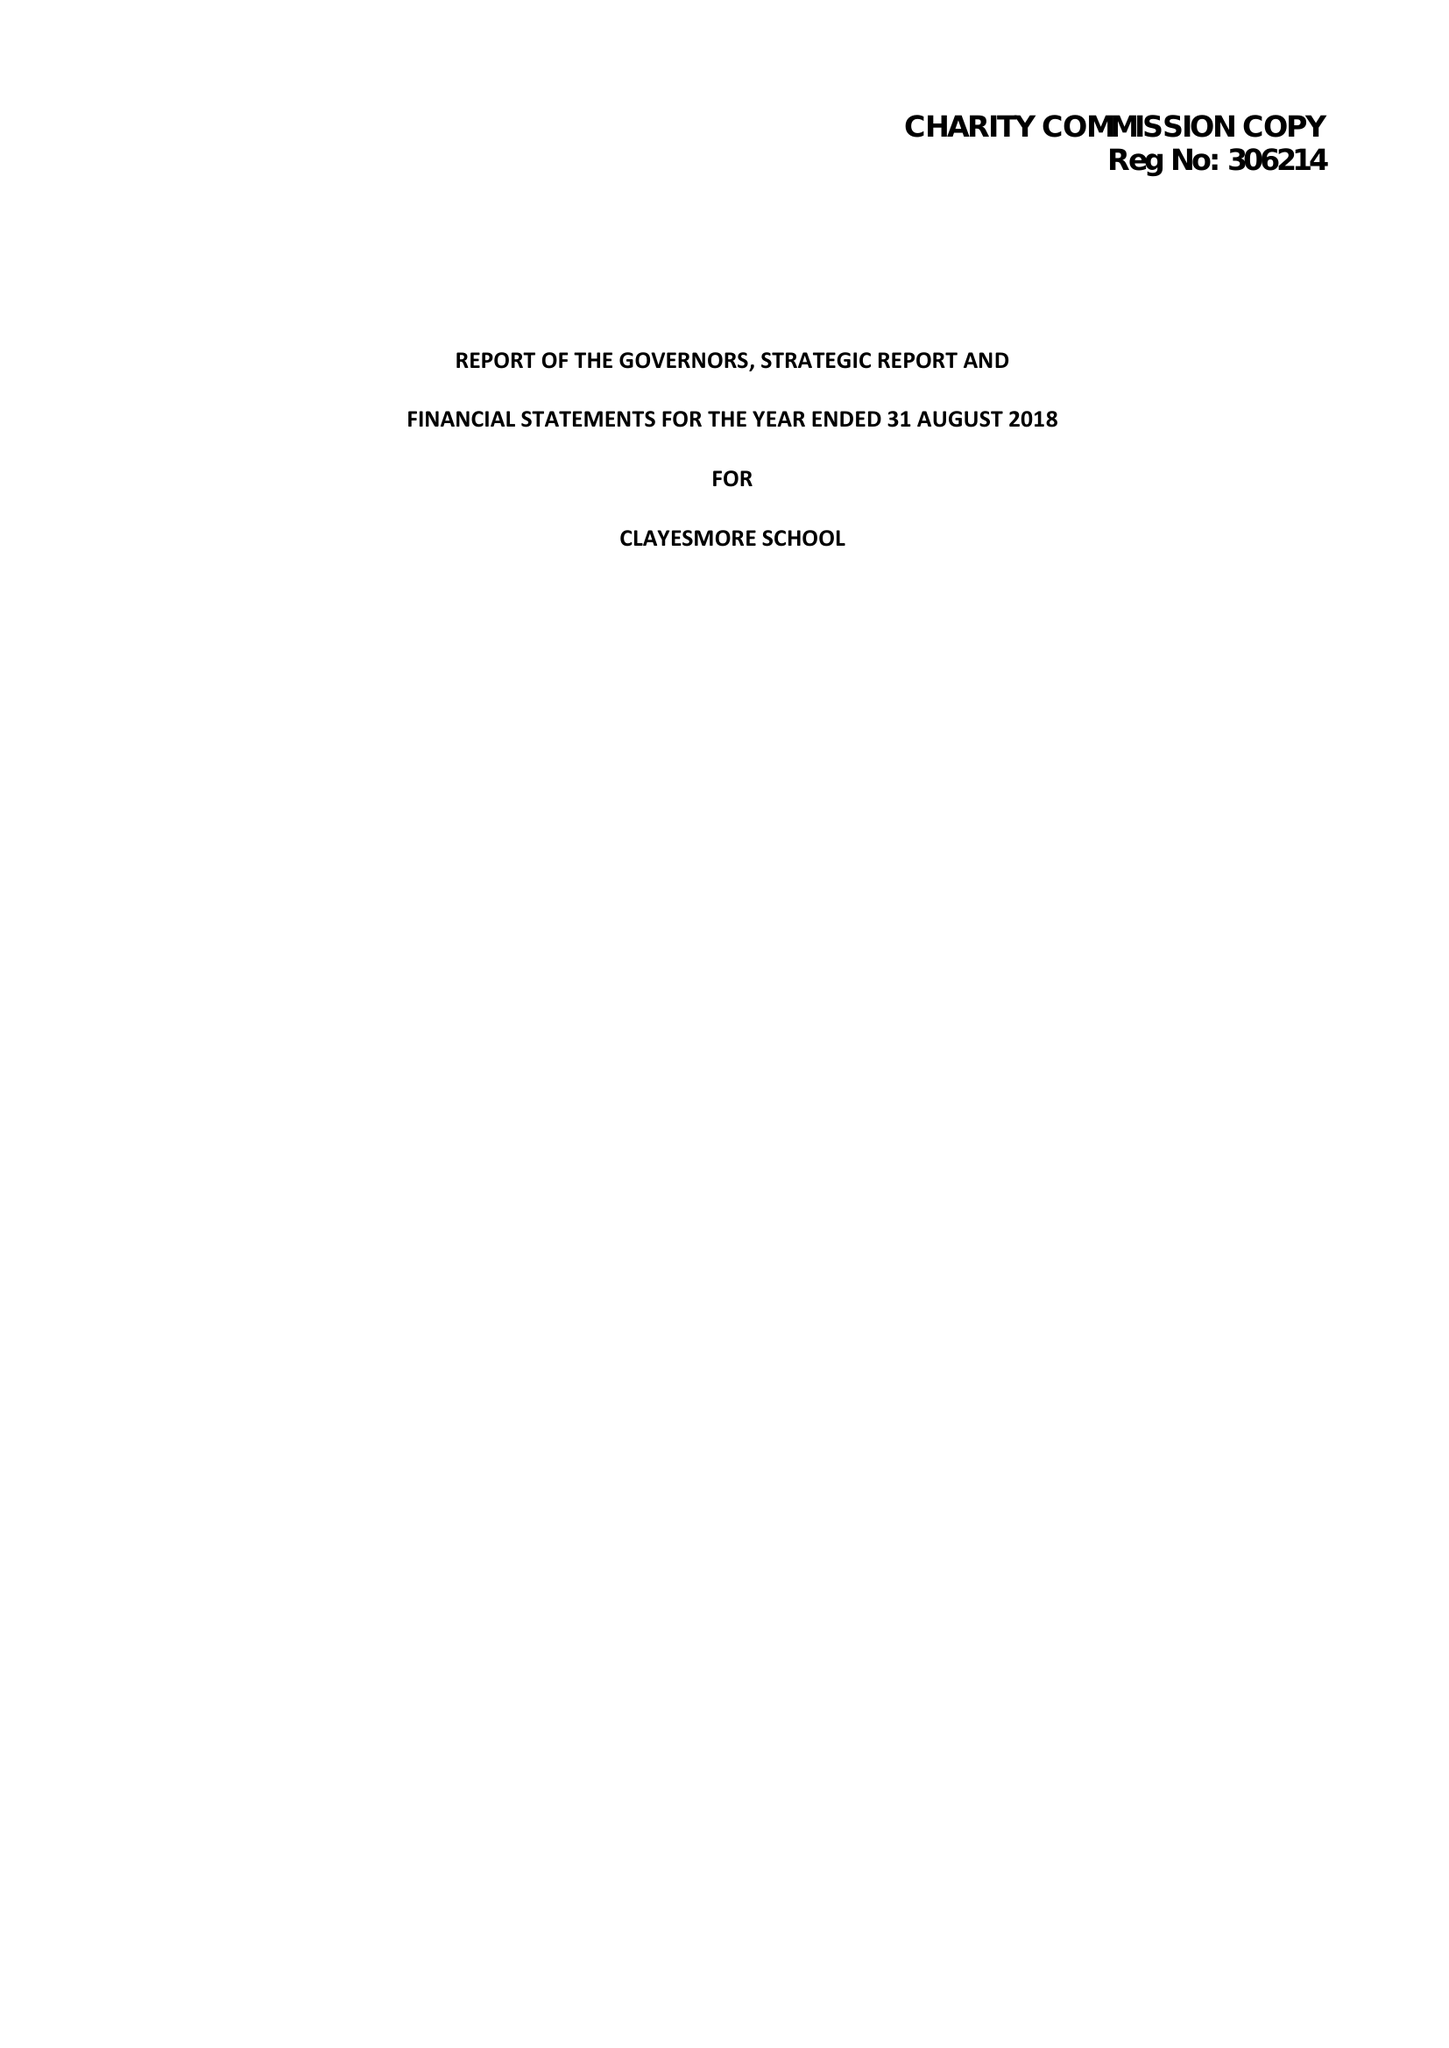What is the value for the income_annually_in_british_pounds?
Answer the question using a single word or phrase. 15207587.00 